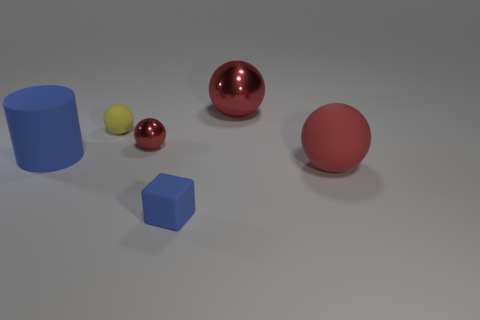What material is the blue object that is to the right of the large cylinder?
Your answer should be compact. Rubber. What color is the tiny metallic object that is the same shape as the tiny yellow rubber object?
Keep it short and to the point. Red. Are there any big red metallic spheres?
Your answer should be very brief. Yes. What is the size of the red matte thing that is the same shape as the yellow thing?
Make the answer very short. Large. There is a red sphere that is behind the small yellow rubber object; how big is it?
Your answer should be compact. Large. Is the number of matte things on the right side of the tiny blue rubber cube greater than the number of brown matte spheres?
Your answer should be very brief. Yes. The yellow thing is what shape?
Give a very brief answer. Sphere. Is the color of the small thing in front of the cylinder the same as the large matte object that is to the left of the tiny red metal sphere?
Ensure brevity in your answer.  Yes. Do the large blue matte object and the large red shiny object have the same shape?
Make the answer very short. No. Are there any other things that are the same shape as the big blue object?
Offer a terse response. No. 